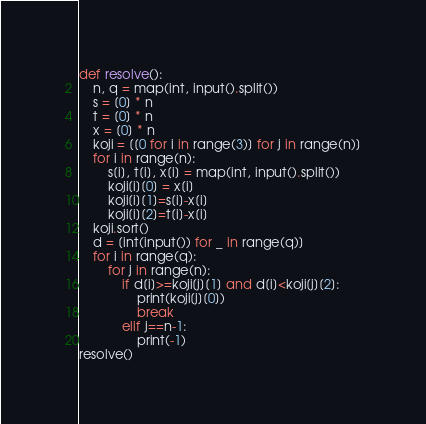<code> <loc_0><loc_0><loc_500><loc_500><_Python_>def resolve():
    n, q = map(int, input().split())
    s = [0] * n
    t = [0] * n
    x = [0] * n
    koji = [[0 for i in range(3)] for j in range(n)]
    for i in range(n):
        s[i], t[i], x[i] = map(int, input().split())
        koji[i][0] = x[i]
        koji[i][1]=s[i]-x[i]
        koji[i][2]=t[i]-x[i]
    koji.sort()
    d = [int(input()) for _ in range(q)]
    for i in range(q):
        for j in range(n):
            if d[i]>=koji[j][1] and d[i]<koji[j][2]:
                print(koji[j][0])
                break
            elif j==n-1:
                print(-1)
resolve()</code> 